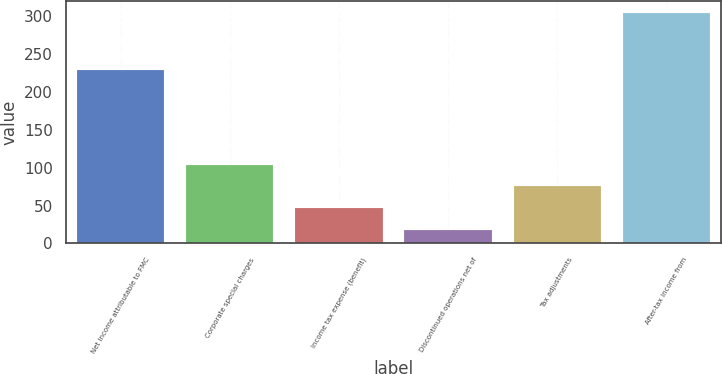Convert chart. <chart><loc_0><loc_0><loc_500><loc_500><bar_chart><fcel>Net income attributable to FMC<fcel>Corporate special charges<fcel>Income tax expense (benefit)<fcel>Discontinued operations net of<fcel>Tax adjustments<fcel>After-tax income from<nl><fcel>228.5<fcel>103.97<fcel>46.79<fcel>18.2<fcel>75.38<fcel>304.1<nl></chart> 